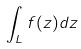<formula> <loc_0><loc_0><loc_500><loc_500>\int _ { L } f ( z ) d z</formula> 